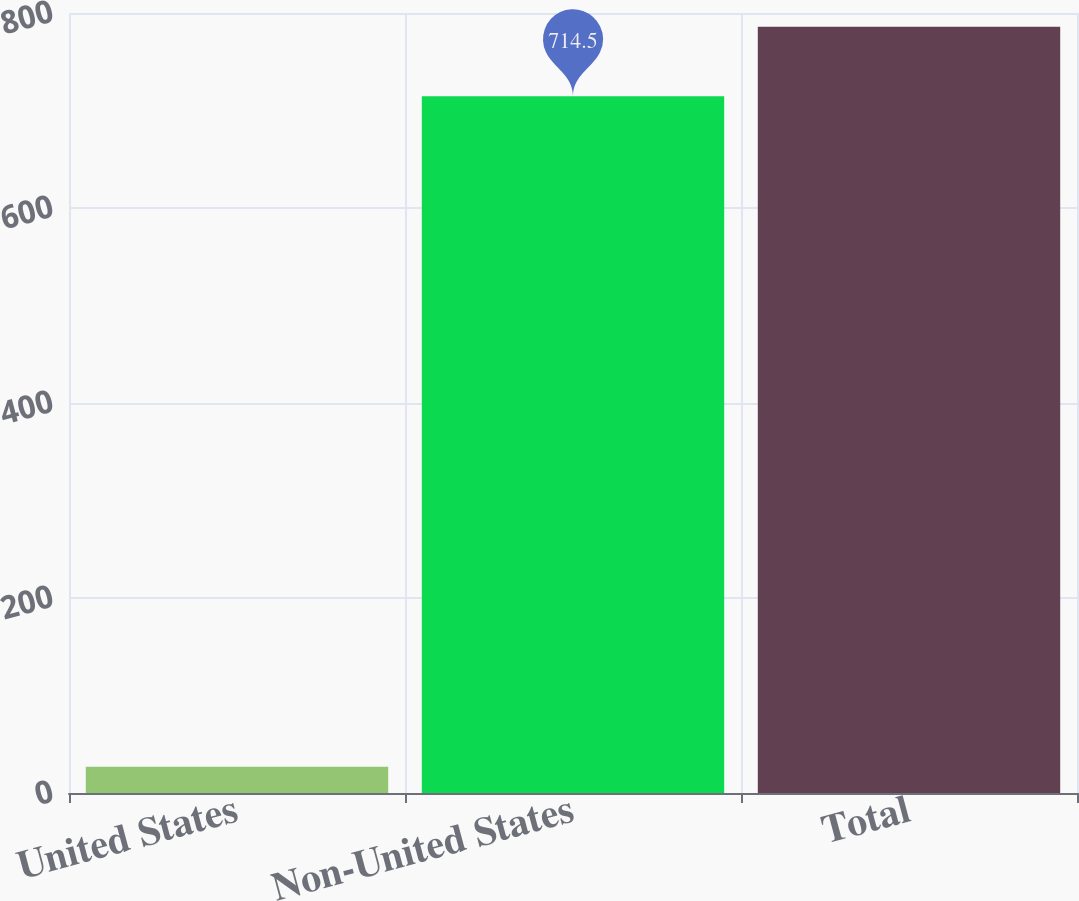Convert chart to OTSL. <chart><loc_0><loc_0><loc_500><loc_500><bar_chart><fcel>United States<fcel>Non-United States<fcel>Total<nl><fcel>26.9<fcel>714.5<fcel>785.95<nl></chart> 